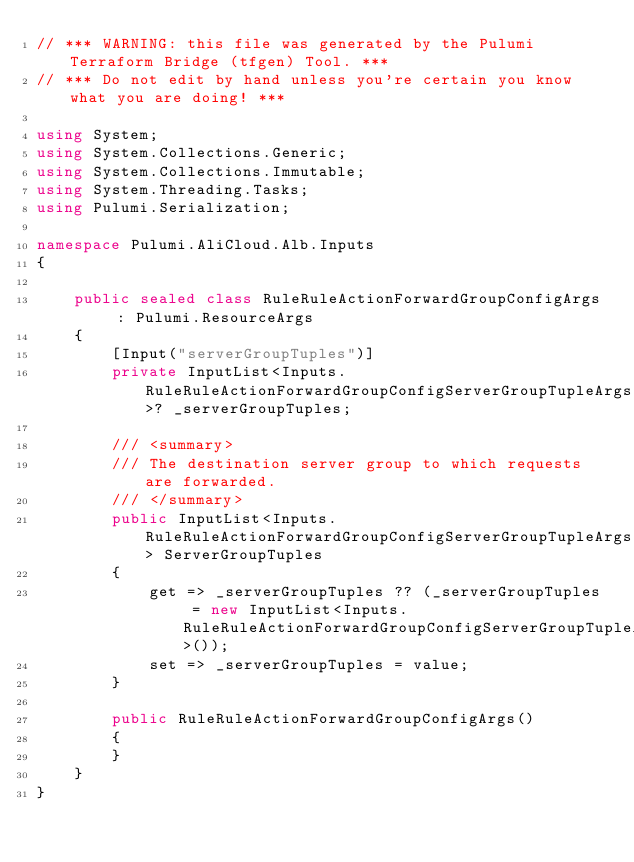Convert code to text. <code><loc_0><loc_0><loc_500><loc_500><_C#_>// *** WARNING: this file was generated by the Pulumi Terraform Bridge (tfgen) Tool. ***
// *** Do not edit by hand unless you're certain you know what you are doing! ***

using System;
using System.Collections.Generic;
using System.Collections.Immutable;
using System.Threading.Tasks;
using Pulumi.Serialization;

namespace Pulumi.AliCloud.Alb.Inputs
{

    public sealed class RuleRuleActionForwardGroupConfigArgs : Pulumi.ResourceArgs
    {
        [Input("serverGroupTuples")]
        private InputList<Inputs.RuleRuleActionForwardGroupConfigServerGroupTupleArgs>? _serverGroupTuples;

        /// <summary>
        /// The destination server group to which requests are forwarded.
        /// </summary>
        public InputList<Inputs.RuleRuleActionForwardGroupConfigServerGroupTupleArgs> ServerGroupTuples
        {
            get => _serverGroupTuples ?? (_serverGroupTuples = new InputList<Inputs.RuleRuleActionForwardGroupConfigServerGroupTupleArgs>());
            set => _serverGroupTuples = value;
        }

        public RuleRuleActionForwardGroupConfigArgs()
        {
        }
    }
}
</code> 